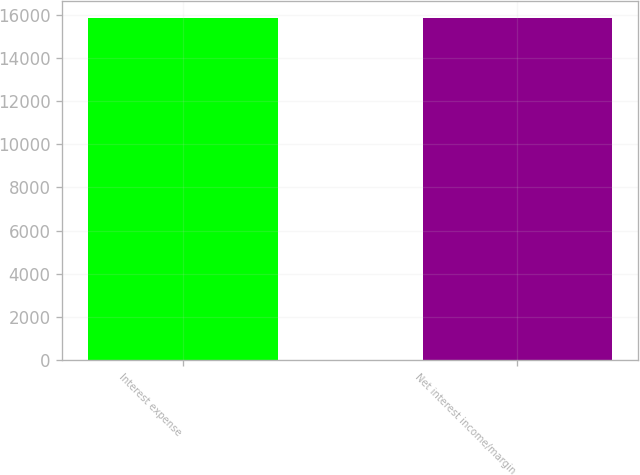Convert chart to OTSL. <chart><loc_0><loc_0><loc_500><loc_500><bar_chart><fcel>Interest expense<fcel>Net interest income/margin<nl><fcel>15857<fcel>15857.1<nl></chart> 